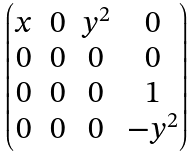Convert formula to latex. <formula><loc_0><loc_0><loc_500><loc_500>\begin{pmatrix} x & 0 & y ^ { 2 } & 0 \\ 0 & 0 & 0 & 0 \\ 0 & 0 & 0 & 1 \\ 0 & 0 & 0 & - y ^ { 2 } \end{pmatrix}</formula> 